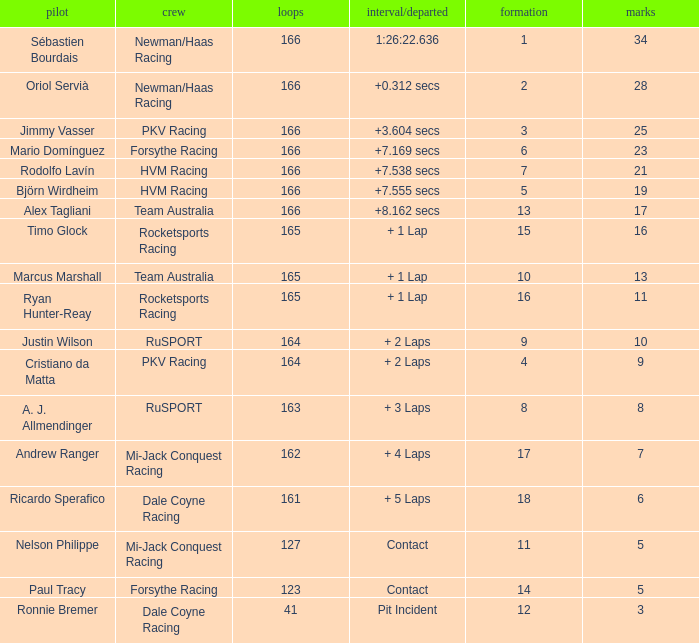Driver Ricardo Sperafico has what as his average laps? 161.0. Write the full table. {'header': ['pilot', 'crew', 'loops', 'interval/departed', 'formation', 'marks'], 'rows': [['Sébastien Bourdais', 'Newman/Haas Racing', '166', '1:26:22.636', '1', '34'], ['Oriol Servià', 'Newman/Haas Racing', '166', '+0.312 secs', '2', '28'], ['Jimmy Vasser', 'PKV Racing', '166', '+3.604 secs', '3', '25'], ['Mario Domínguez', 'Forsythe Racing', '166', '+7.169 secs', '6', '23'], ['Rodolfo Lavín', 'HVM Racing', '166', '+7.538 secs', '7', '21'], ['Björn Wirdheim', 'HVM Racing', '166', '+7.555 secs', '5', '19'], ['Alex Tagliani', 'Team Australia', '166', '+8.162 secs', '13', '17'], ['Timo Glock', 'Rocketsports Racing', '165', '+ 1 Lap', '15', '16'], ['Marcus Marshall', 'Team Australia', '165', '+ 1 Lap', '10', '13'], ['Ryan Hunter-Reay', 'Rocketsports Racing', '165', '+ 1 Lap', '16', '11'], ['Justin Wilson', 'RuSPORT', '164', '+ 2 Laps', '9', '10'], ['Cristiano da Matta', 'PKV Racing', '164', '+ 2 Laps', '4', '9'], ['A. J. Allmendinger', 'RuSPORT', '163', '+ 3 Laps', '8', '8'], ['Andrew Ranger', 'Mi-Jack Conquest Racing', '162', '+ 4 Laps', '17', '7'], ['Ricardo Sperafico', 'Dale Coyne Racing', '161', '+ 5 Laps', '18', '6'], ['Nelson Philippe', 'Mi-Jack Conquest Racing', '127', 'Contact', '11', '5'], ['Paul Tracy', 'Forsythe Racing', '123', 'Contact', '14', '5'], ['Ronnie Bremer', 'Dale Coyne Racing', '41', 'Pit Incident', '12', '3']]} 